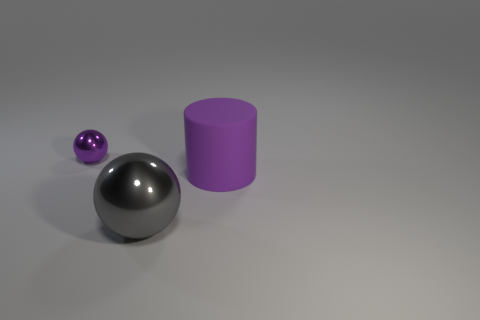What is the color of the thing that is both left of the purple matte thing and on the right side of the tiny sphere?
Offer a very short reply. Gray. What number of gray metallic spheres are there?
Your answer should be compact. 1. Is there any other thing that is the same size as the purple shiny sphere?
Offer a terse response. No. Is the material of the gray thing the same as the cylinder?
Your answer should be very brief. No. Do the metal sphere that is in front of the small ball and the ball to the left of the large gray metallic object have the same size?
Your answer should be compact. No. Are there fewer tiny things than tiny blue metal objects?
Give a very brief answer. No. How many matte objects are large gray balls or cyan spheres?
Your answer should be compact. 0. There is a gray metallic thing that is in front of the tiny metal thing; are there any purple matte things in front of it?
Keep it short and to the point. No. Are the purple thing that is behind the purple cylinder and the big ball made of the same material?
Provide a succinct answer. Yes. How many other objects are the same color as the small metallic sphere?
Offer a very short reply. 1. 